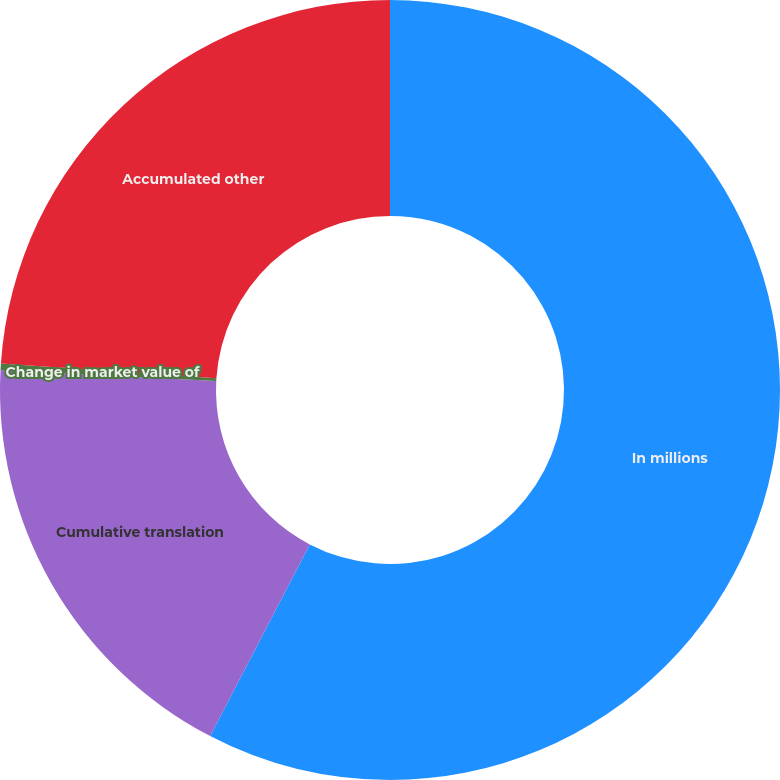Convert chart. <chart><loc_0><loc_0><loc_500><loc_500><pie_chart><fcel>In millions<fcel>Cumulative translation<fcel>Change in market value of<fcel>Accumulated other<nl><fcel>57.63%<fcel>18.19%<fcel>0.26%<fcel>23.92%<nl></chart> 